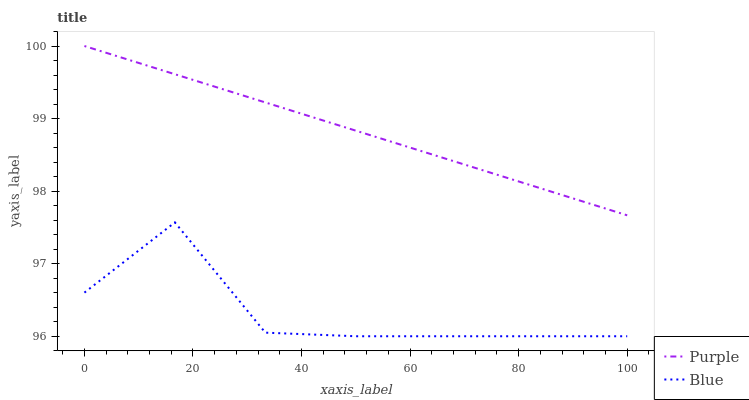Does Blue have the maximum area under the curve?
Answer yes or no. No. Is Blue the smoothest?
Answer yes or no. No. Does Blue have the highest value?
Answer yes or no. No. Is Blue less than Purple?
Answer yes or no. Yes. Is Purple greater than Blue?
Answer yes or no. Yes. Does Blue intersect Purple?
Answer yes or no. No. 